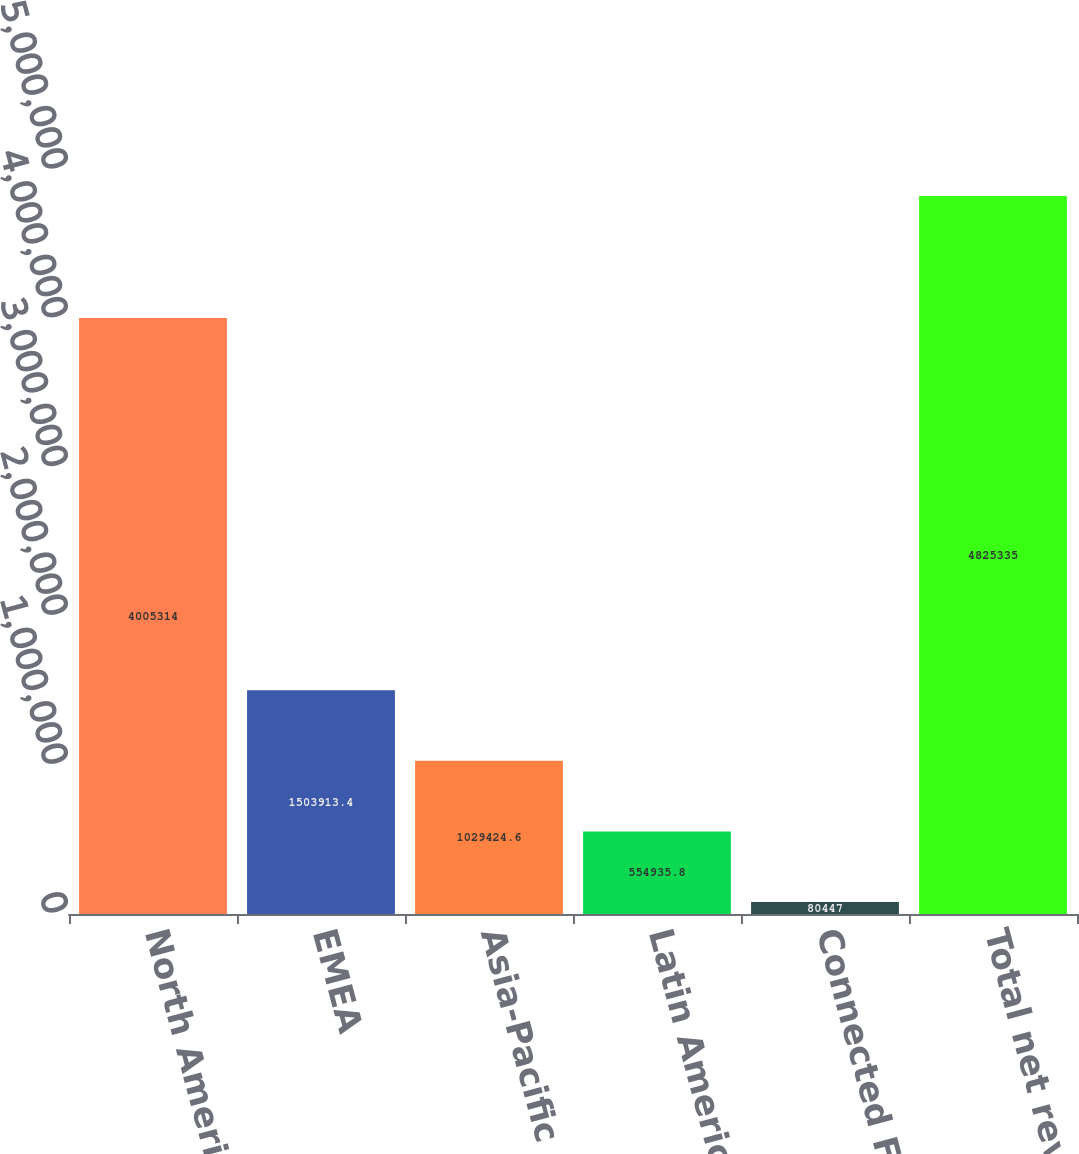Convert chart. <chart><loc_0><loc_0><loc_500><loc_500><bar_chart><fcel>North America<fcel>EMEA<fcel>Asia-Pacific<fcel>Latin America<fcel>Connected Fitness<fcel>Total net revenues<nl><fcel>4.00531e+06<fcel>1.50391e+06<fcel>1.02942e+06<fcel>554936<fcel>80447<fcel>4.82534e+06<nl></chart> 